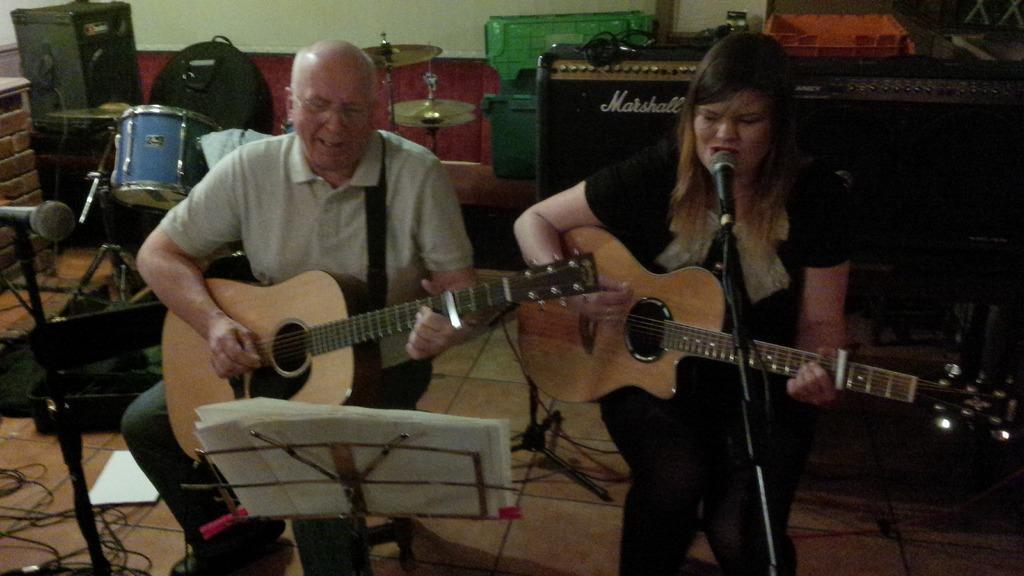Can you describe this image briefly? In this image there is a man and a woman holding a guitar, the woman is singing in front of a micro phone,there are few papers on the stand, at the back ground there few musical instruments and a wall. 